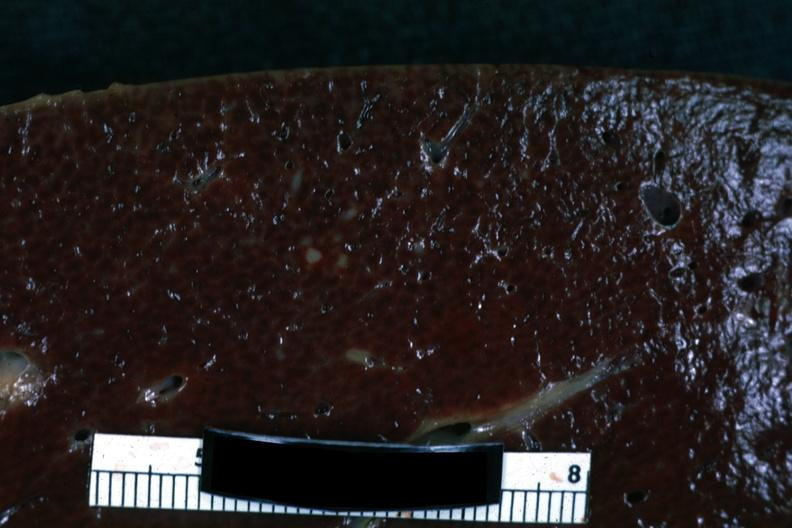what is present?
Answer the question using a single word or phrase. Hematologic 